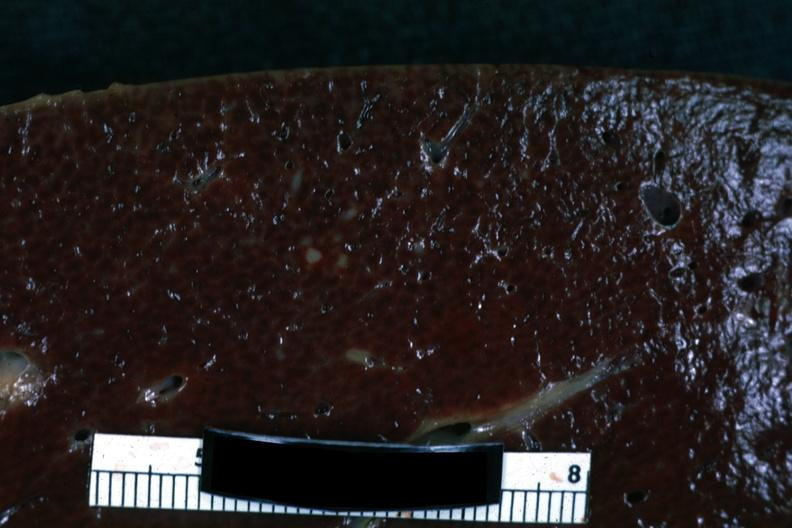what is present?
Answer the question using a single word or phrase. Hematologic 